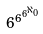<formula> <loc_0><loc_0><loc_500><loc_500>6 ^ { 6 ^ { 6 ^ { \aleph _ { 0 } } } }</formula> 